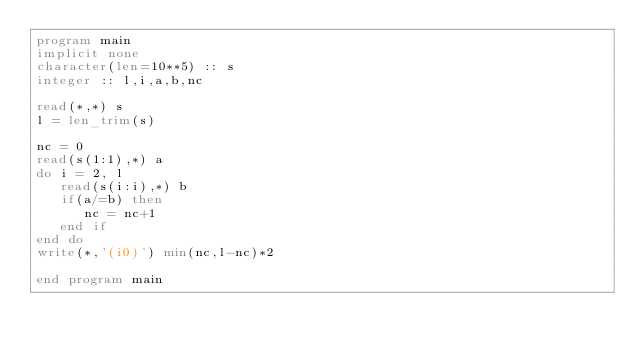Convert code to text. <code><loc_0><loc_0><loc_500><loc_500><_FORTRAN_>program main
implicit none
character(len=10**5) :: s
integer :: l,i,a,b,nc

read(*,*) s
l = len_trim(s)

nc = 0
read(s(1:1),*) a
do i = 2, l
   read(s(i:i),*) b
   if(a/=b) then
      nc = nc+1
   end if
end do
write(*,'(i0)') min(nc,l-nc)*2

end program main
</code> 